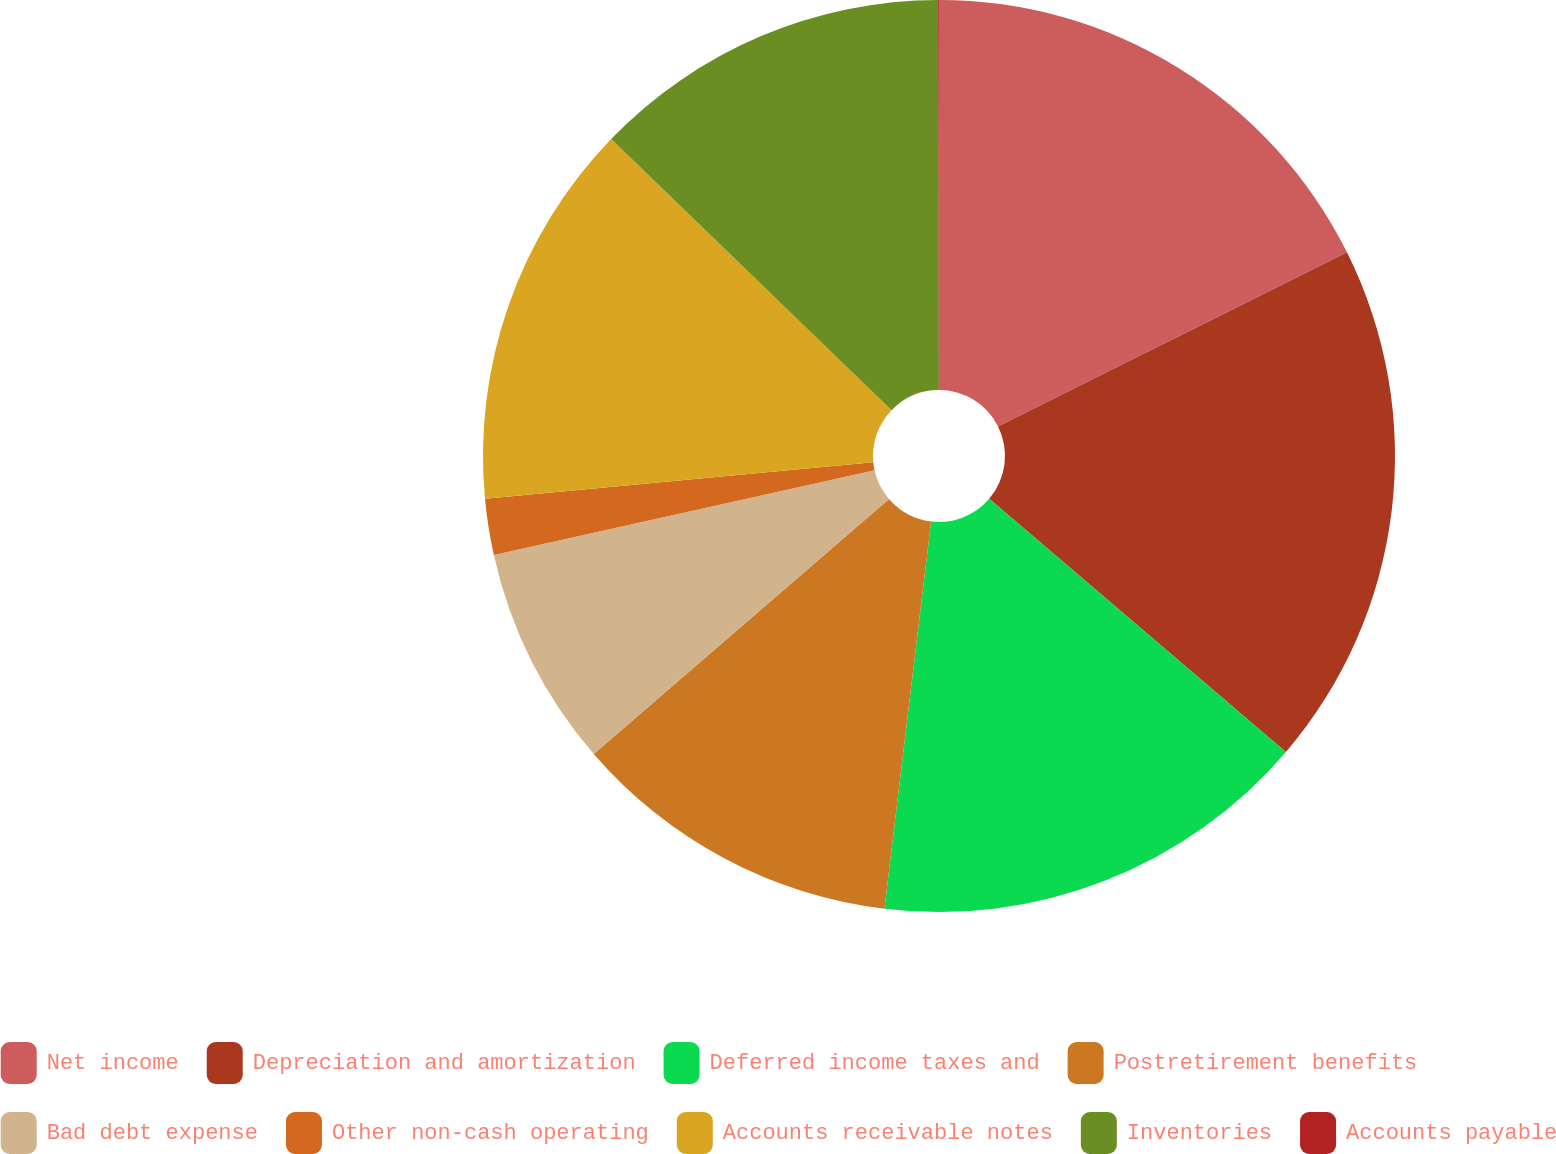<chart> <loc_0><loc_0><loc_500><loc_500><pie_chart><fcel>Net income<fcel>Depreciation and amortization<fcel>Deferred income taxes and<fcel>Postretirement benefits<fcel>Bad debt expense<fcel>Other non-cash operating<fcel>Accounts receivable notes<fcel>Inventories<fcel>Accounts payable<nl><fcel>17.63%<fcel>18.61%<fcel>15.67%<fcel>11.76%<fcel>7.85%<fcel>1.99%<fcel>13.72%<fcel>12.74%<fcel>0.03%<nl></chart> 